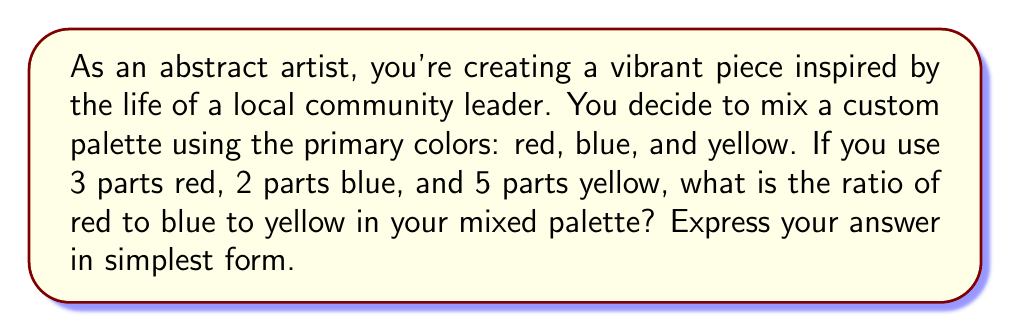Provide a solution to this math problem. Let's approach this step-by-step:

1) First, let's identify the parts of each color:
   Red: 3 parts
   Blue: 2 parts
   Yellow: 5 parts

2) To express the ratio, we write these numbers in order:
   $$3 : 2 : 5$$

3) This ratio is already in its simplest form because there is no common factor that divides all three numbers evenly.

4) Therefore, the ratio of red to blue to yellow is 3:2:5.

This ratio tells us that for every 3 parts of red, there are 2 parts of blue and 5 parts of yellow in the mixed palette.
Answer: $3:2:5$ 